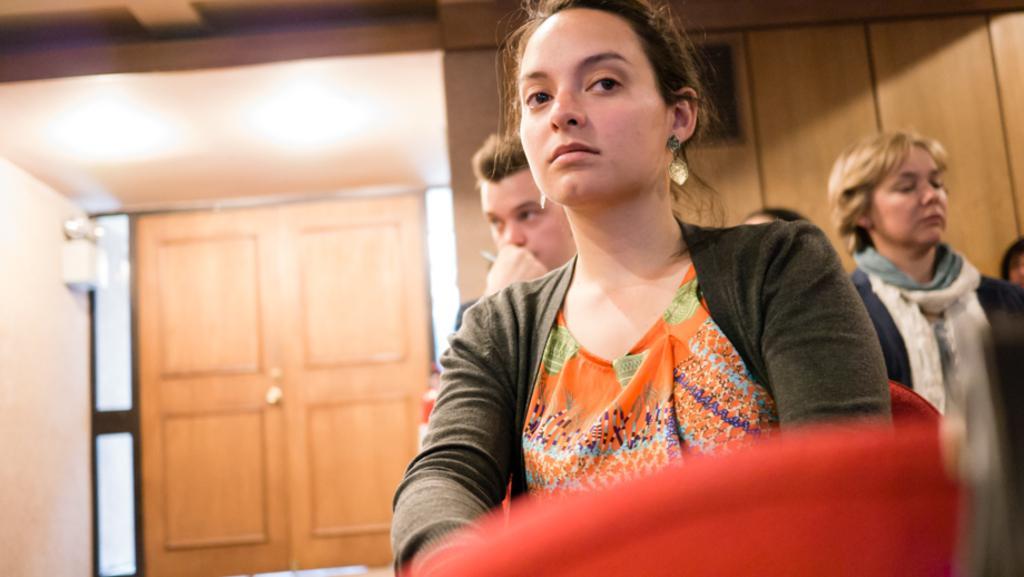Please provide a concise description of this image. The woman in orange dress and black jacket is looking at the camera. Behind her, we see people standing. In front of her, we see a red color thing. Behind them, we see a wall and a door. This picture is clicked inside the room. 